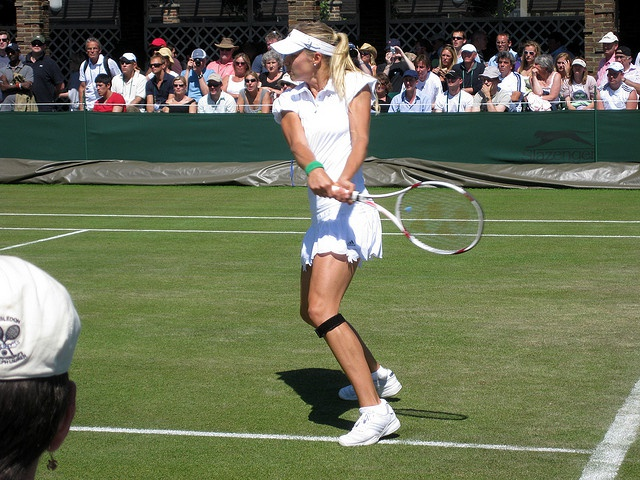Describe the objects in this image and their specific colors. I can see people in black, white, gray, and darkgray tones, people in black, white, salmon, brown, and tan tones, tennis racket in black, olive, and white tones, people in black, lavender, gray, and brown tones, and people in black, lightgray, gray, and darkgray tones in this image. 